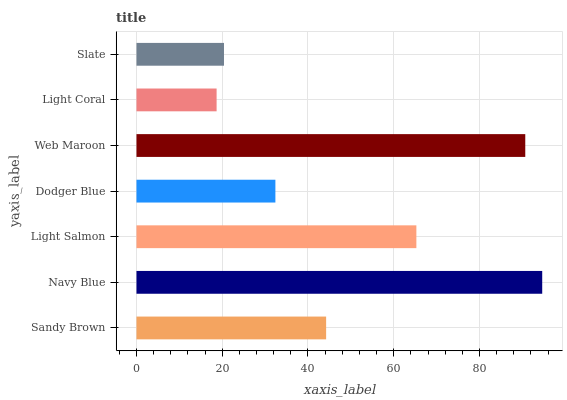Is Light Coral the minimum?
Answer yes or no. Yes. Is Navy Blue the maximum?
Answer yes or no. Yes. Is Light Salmon the minimum?
Answer yes or no. No. Is Light Salmon the maximum?
Answer yes or no. No. Is Navy Blue greater than Light Salmon?
Answer yes or no. Yes. Is Light Salmon less than Navy Blue?
Answer yes or no. Yes. Is Light Salmon greater than Navy Blue?
Answer yes or no. No. Is Navy Blue less than Light Salmon?
Answer yes or no. No. Is Sandy Brown the high median?
Answer yes or no. Yes. Is Sandy Brown the low median?
Answer yes or no. Yes. Is Navy Blue the high median?
Answer yes or no. No. Is Web Maroon the low median?
Answer yes or no. No. 